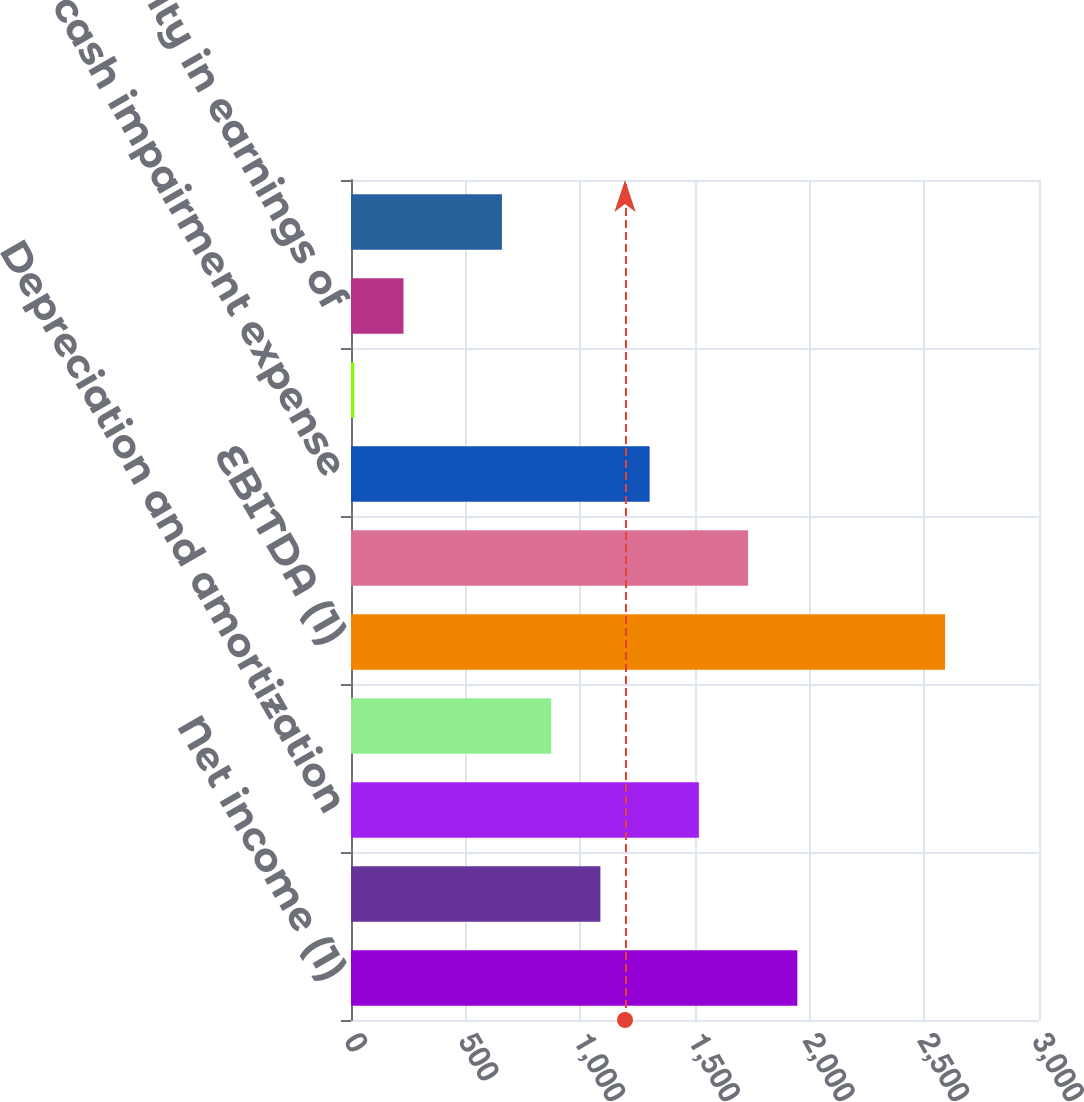<chart> <loc_0><loc_0><loc_500><loc_500><bar_chart><fcel>Net income (1)<fcel>Interest expense<fcel>Depreciation and amortization<fcel>Income taxes<fcel>EBITDA (1)<fcel>Gain on dispositions (2)<fcel>Non-cash impairment expense<fcel>Equity in earnings of Euro JV<fcel>Equity in earnings of<fcel>Pro rata EBITDA re of Euro JV<nl><fcel>1946.3<fcel>1087.5<fcel>1516.9<fcel>872.8<fcel>2590.4<fcel>1731.6<fcel>1302.2<fcel>14<fcel>228.7<fcel>658.1<nl></chart> 